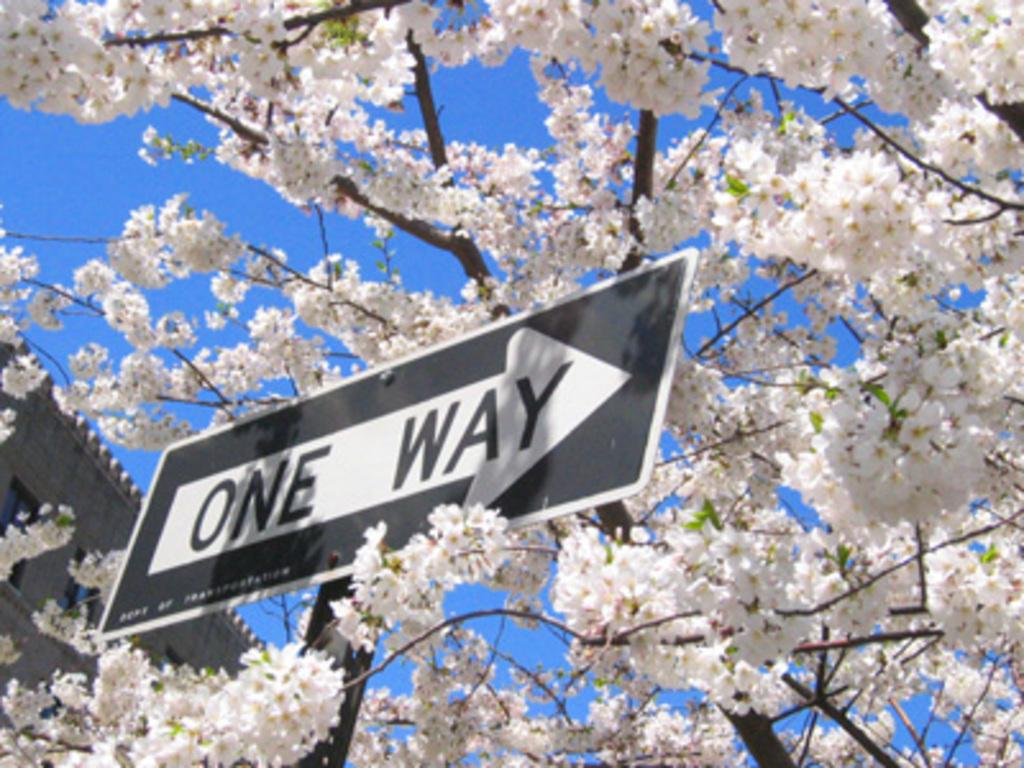What is the main object in the image? There is a sign board in the image. What type of tree can be seen in the image? There is a tree with flowers in the image. What structure is visible in the image? There is a building in the image. What is visible in the background of the image? The sky is visible in the image. What type of toothpaste is the grandmother using in the image? There is no grandmother or toothpaste present in the image. 